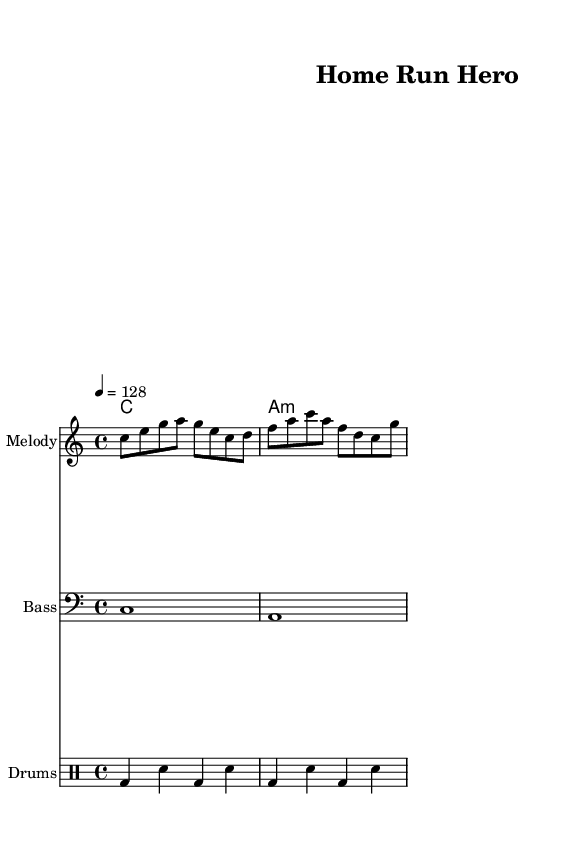What key is this piece in? The key signature is indicated by the absence of sharps or flats, which means it is in C major.
Answer: C major What is the time signature of this music? The time signature is shown as 4/4 at the beginning of the staff, indicating four beats per measure.
Answer: 4/4 What is the tempo marking of the piece? The tempo is marked as quarter note equals 128, which denotes the speed of the music.
Answer: 128 How many measures are in the melody part? Counting the measures notated in the melody, there are a total of 2 measures present.
Answer: 2 Which instruments are included in the score? The score includes a melody staff, bass staff, and drum staff, indicating the different parts played in the music.
Answer: Melody, Bass, Drums What kind of musical piece is this? The combination of energetic melody, driving bass, and rhythmic drums without lyrics suggests that this is an instrumental K-Pop track.
Answer: Instrumental K-Pop What is the first note of the melody? The melody starts with the note C, as indicated in the first measure's notation.
Answer: C 